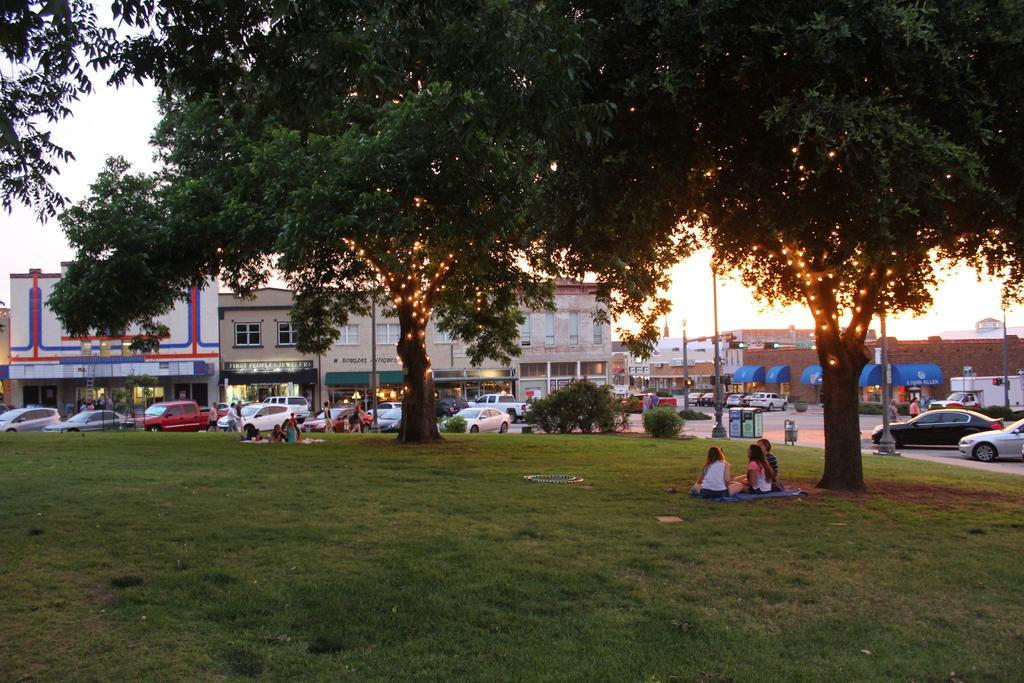Describe this image in one or two sentences. At the bottom of the image there is grass. In the middle of the image few people are standing and sitting. Behind them there are some plants and vehicles and poles and trees. Behind the trees there are some buildings and sky. 